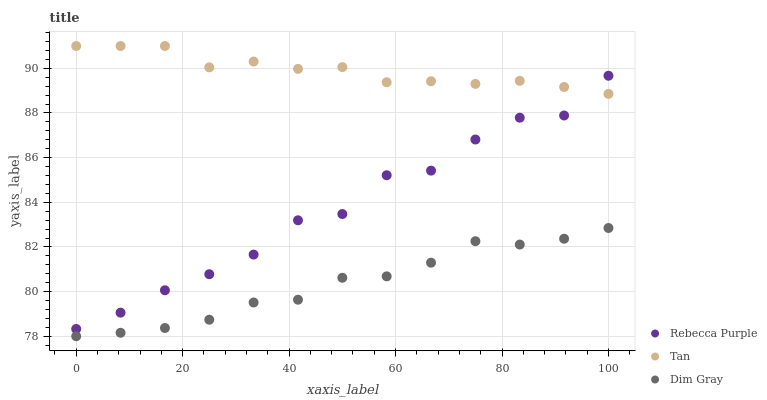Does Dim Gray have the minimum area under the curve?
Answer yes or no. Yes. Does Tan have the maximum area under the curve?
Answer yes or no. Yes. Does Rebecca Purple have the minimum area under the curve?
Answer yes or no. No. Does Rebecca Purple have the maximum area under the curve?
Answer yes or no. No. Is Tan the smoothest?
Answer yes or no. Yes. Is Rebecca Purple the roughest?
Answer yes or no. Yes. Is Dim Gray the smoothest?
Answer yes or no. No. Is Dim Gray the roughest?
Answer yes or no. No. Does Dim Gray have the lowest value?
Answer yes or no. Yes. Does Rebecca Purple have the lowest value?
Answer yes or no. No. Does Tan have the highest value?
Answer yes or no. Yes. Does Rebecca Purple have the highest value?
Answer yes or no. No. Is Dim Gray less than Tan?
Answer yes or no. Yes. Is Rebecca Purple greater than Dim Gray?
Answer yes or no. Yes. Does Tan intersect Rebecca Purple?
Answer yes or no. Yes. Is Tan less than Rebecca Purple?
Answer yes or no. No. Is Tan greater than Rebecca Purple?
Answer yes or no. No. Does Dim Gray intersect Tan?
Answer yes or no. No. 